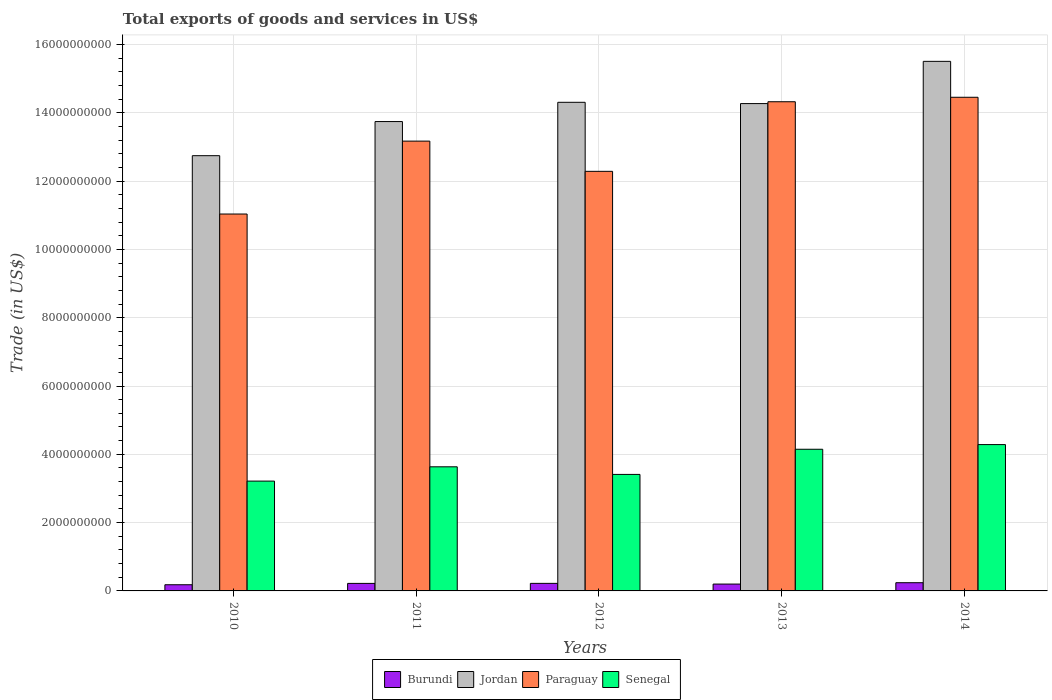How many groups of bars are there?
Your answer should be compact. 5. Are the number of bars per tick equal to the number of legend labels?
Offer a terse response. Yes. What is the label of the 3rd group of bars from the left?
Your answer should be compact. 2012. In how many cases, is the number of bars for a given year not equal to the number of legend labels?
Your answer should be compact. 0. What is the total exports of goods and services in Senegal in 2010?
Keep it short and to the point. 3.22e+09. Across all years, what is the maximum total exports of goods and services in Paraguay?
Provide a succinct answer. 1.45e+1. Across all years, what is the minimum total exports of goods and services in Senegal?
Offer a terse response. 3.22e+09. In which year was the total exports of goods and services in Paraguay minimum?
Offer a very short reply. 2010. What is the total total exports of goods and services in Burundi in the graph?
Provide a succinct answer. 1.06e+09. What is the difference between the total exports of goods and services in Paraguay in 2010 and that in 2011?
Provide a succinct answer. -2.13e+09. What is the difference between the total exports of goods and services in Senegal in 2011 and the total exports of goods and services in Paraguay in 2013?
Ensure brevity in your answer.  -1.07e+1. What is the average total exports of goods and services in Burundi per year?
Your response must be concise. 2.13e+08. In the year 2012, what is the difference between the total exports of goods and services in Burundi and total exports of goods and services in Paraguay?
Provide a succinct answer. -1.21e+1. In how many years, is the total exports of goods and services in Paraguay greater than 13600000000 US$?
Provide a succinct answer. 2. What is the ratio of the total exports of goods and services in Burundi in 2010 to that in 2012?
Your response must be concise. 0.82. What is the difference between the highest and the second highest total exports of goods and services in Jordan?
Offer a terse response. 1.20e+09. What is the difference between the highest and the lowest total exports of goods and services in Senegal?
Offer a very short reply. 1.07e+09. In how many years, is the total exports of goods and services in Senegal greater than the average total exports of goods and services in Senegal taken over all years?
Offer a terse response. 2. What does the 3rd bar from the left in 2014 represents?
Your answer should be very brief. Paraguay. What does the 4th bar from the right in 2011 represents?
Ensure brevity in your answer.  Burundi. Is it the case that in every year, the sum of the total exports of goods and services in Paraguay and total exports of goods and services in Jordan is greater than the total exports of goods and services in Senegal?
Offer a terse response. Yes. How many bars are there?
Provide a succinct answer. 20. Are all the bars in the graph horizontal?
Offer a very short reply. No. How many years are there in the graph?
Provide a succinct answer. 5. Does the graph contain grids?
Your answer should be very brief. Yes. What is the title of the graph?
Your answer should be compact. Total exports of goods and services in US$. Does "Latvia" appear as one of the legend labels in the graph?
Offer a terse response. No. What is the label or title of the X-axis?
Offer a very short reply. Years. What is the label or title of the Y-axis?
Keep it short and to the point. Trade (in US$). What is the Trade (in US$) in Burundi in 2010?
Provide a short and direct response. 1.81e+08. What is the Trade (in US$) in Jordan in 2010?
Provide a short and direct response. 1.27e+1. What is the Trade (in US$) in Paraguay in 2010?
Your answer should be very brief. 1.10e+1. What is the Trade (in US$) in Senegal in 2010?
Keep it short and to the point. 3.22e+09. What is the Trade (in US$) in Burundi in 2011?
Make the answer very short. 2.20e+08. What is the Trade (in US$) in Jordan in 2011?
Give a very brief answer. 1.37e+1. What is the Trade (in US$) of Paraguay in 2011?
Keep it short and to the point. 1.32e+1. What is the Trade (in US$) in Senegal in 2011?
Offer a terse response. 3.63e+09. What is the Trade (in US$) of Burundi in 2012?
Make the answer very short. 2.21e+08. What is the Trade (in US$) in Jordan in 2012?
Offer a very short reply. 1.43e+1. What is the Trade (in US$) in Paraguay in 2012?
Offer a very short reply. 1.23e+1. What is the Trade (in US$) of Senegal in 2012?
Your answer should be compact. 3.41e+09. What is the Trade (in US$) in Burundi in 2013?
Make the answer very short. 2.01e+08. What is the Trade (in US$) in Jordan in 2013?
Keep it short and to the point. 1.43e+1. What is the Trade (in US$) in Paraguay in 2013?
Offer a very short reply. 1.43e+1. What is the Trade (in US$) in Senegal in 2013?
Offer a terse response. 4.15e+09. What is the Trade (in US$) in Burundi in 2014?
Offer a terse response. 2.40e+08. What is the Trade (in US$) of Jordan in 2014?
Make the answer very short. 1.55e+1. What is the Trade (in US$) of Paraguay in 2014?
Provide a succinct answer. 1.45e+1. What is the Trade (in US$) in Senegal in 2014?
Offer a terse response. 4.29e+09. Across all years, what is the maximum Trade (in US$) of Burundi?
Ensure brevity in your answer.  2.40e+08. Across all years, what is the maximum Trade (in US$) of Jordan?
Provide a succinct answer. 1.55e+1. Across all years, what is the maximum Trade (in US$) in Paraguay?
Your answer should be compact. 1.45e+1. Across all years, what is the maximum Trade (in US$) in Senegal?
Ensure brevity in your answer.  4.29e+09. Across all years, what is the minimum Trade (in US$) of Burundi?
Offer a terse response. 1.81e+08. Across all years, what is the minimum Trade (in US$) of Jordan?
Your answer should be compact. 1.27e+1. Across all years, what is the minimum Trade (in US$) in Paraguay?
Your answer should be compact. 1.10e+1. Across all years, what is the minimum Trade (in US$) in Senegal?
Your response must be concise. 3.22e+09. What is the total Trade (in US$) of Burundi in the graph?
Your answer should be compact. 1.06e+09. What is the total Trade (in US$) in Jordan in the graph?
Offer a terse response. 7.06e+1. What is the total Trade (in US$) of Paraguay in the graph?
Make the answer very short. 6.53e+1. What is the total Trade (in US$) of Senegal in the graph?
Keep it short and to the point. 1.87e+1. What is the difference between the Trade (in US$) of Burundi in 2010 and that in 2011?
Offer a terse response. -3.96e+07. What is the difference between the Trade (in US$) of Jordan in 2010 and that in 2011?
Make the answer very short. -9.99e+08. What is the difference between the Trade (in US$) of Paraguay in 2010 and that in 2011?
Keep it short and to the point. -2.13e+09. What is the difference between the Trade (in US$) in Senegal in 2010 and that in 2011?
Provide a short and direct response. -4.19e+08. What is the difference between the Trade (in US$) of Burundi in 2010 and that in 2012?
Ensure brevity in your answer.  -4.06e+07. What is the difference between the Trade (in US$) of Jordan in 2010 and that in 2012?
Give a very brief answer. -1.56e+09. What is the difference between the Trade (in US$) in Paraguay in 2010 and that in 2012?
Your answer should be compact. -1.25e+09. What is the difference between the Trade (in US$) in Senegal in 2010 and that in 2012?
Your answer should be compact. -1.96e+08. What is the difference between the Trade (in US$) of Burundi in 2010 and that in 2013?
Your answer should be compact. -2.00e+07. What is the difference between the Trade (in US$) in Jordan in 2010 and that in 2013?
Ensure brevity in your answer.  -1.53e+09. What is the difference between the Trade (in US$) in Paraguay in 2010 and that in 2013?
Your answer should be very brief. -3.29e+09. What is the difference between the Trade (in US$) in Senegal in 2010 and that in 2013?
Keep it short and to the point. -9.32e+08. What is the difference between the Trade (in US$) of Burundi in 2010 and that in 2014?
Ensure brevity in your answer.  -5.96e+07. What is the difference between the Trade (in US$) of Jordan in 2010 and that in 2014?
Keep it short and to the point. -2.76e+09. What is the difference between the Trade (in US$) in Paraguay in 2010 and that in 2014?
Provide a short and direct response. -3.42e+09. What is the difference between the Trade (in US$) of Senegal in 2010 and that in 2014?
Offer a terse response. -1.07e+09. What is the difference between the Trade (in US$) of Burundi in 2011 and that in 2012?
Provide a succinct answer. -9.41e+05. What is the difference between the Trade (in US$) in Jordan in 2011 and that in 2012?
Give a very brief answer. -5.64e+08. What is the difference between the Trade (in US$) in Paraguay in 2011 and that in 2012?
Provide a succinct answer. 8.85e+08. What is the difference between the Trade (in US$) in Senegal in 2011 and that in 2012?
Your answer should be compact. 2.23e+08. What is the difference between the Trade (in US$) of Burundi in 2011 and that in 2013?
Keep it short and to the point. 1.96e+07. What is the difference between the Trade (in US$) in Jordan in 2011 and that in 2013?
Give a very brief answer. -5.26e+08. What is the difference between the Trade (in US$) in Paraguay in 2011 and that in 2013?
Your answer should be very brief. -1.15e+09. What is the difference between the Trade (in US$) of Senegal in 2011 and that in 2013?
Your response must be concise. -5.14e+08. What is the difference between the Trade (in US$) of Burundi in 2011 and that in 2014?
Ensure brevity in your answer.  -2.00e+07. What is the difference between the Trade (in US$) of Jordan in 2011 and that in 2014?
Ensure brevity in your answer.  -1.76e+09. What is the difference between the Trade (in US$) of Paraguay in 2011 and that in 2014?
Provide a short and direct response. -1.28e+09. What is the difference between the Trade (in US$) in Senegal in 2011 and that in 2014?
Your answer should be compact. -6.51e+08. What is the difference between the Trade (in US$) of Burundi in 2012 and that in 2013?
Provide a short and direct response. 2.05e+07. What is the difference between the Trade (in US$) in Jordan in 2012 and that in 2013?
Your response must be concise. 3.72e+07. What is the difference between the Trade (in US$) in Paraguay in 2012 and that in 2013?
Ensure brevity in your answer.  -2.04e+09. What is the difference between the Trade (in US$) of Senegal in 2012 and that in 2013?
Give a very brief answer. -7.36e+08. What is the difference between the Trade (in US$) of Burundi in 2012 and that in 2014?
Give a very brief answer. -1.90e+07. What is the difference between the Trade (in US$) in Jordan in 2012 and that in 2014?
Offer a very short reply. -1.20e+09. What is the difference between the Trade (in US$) of Paraguay in 2012 and that in 2014?
Keep it short and to the point. -2.17e+09. What is the difference between the Trade (in US$) in Senegal in 2012 and that in 2014?
Your answer should be compact. -8.73e+08. What is the difference between the Trade (in US$) in Burundi in 2013 and that in 2014?
Your answer should be very brief. -3.96e+07. What is the difference between the Trade (in US$) of Jordan in 2013 and that in 2014?
Offer a very short reply. -1.24e+09. What is the difference between the Trade (in US$) of Paraguay in 2013 and that in 2014?
Your response must be concise. -1.31e+08. What is the difference between the Trade (in US$) of Senegal in 2013 and that in 2014?
Make the answer very short. -1.37e+08. What is the difference between the Trade (in US$) of Burundi in 2010 and the Trade (in US$) of Jordan in 2011?
Offer a very short reply. -1.36e+1. What is the difference between the Trade (in US$) of Burundi in 2010 and the Trade (in US$) of Paraguay in 2011?
Your answer should be very brief. -1.30e+1. What is the difference between the Trade (in US$) of Burundi in 2010 and the Trade (in US$) of Senegal in 2011?
Ensure brevity in your answer.  -3.45e+09. What is the difference between the Trade (in US$) of Jordan in 2010 and the Trade (in US$) of Paraguay in 2011?
Give a very brief answer. -4.27e+08. What is the difference between the Trade (in US$) of Jordan in 2010 and the Trade (in US$) of Senegal in 2011?
Your answer should be very brief. 9.11e+09. What is the difference between the Trade (in US$) of Paraguay in 2010 and the Trade (in US$) of Senegal in 2011?
Make the answer very short. 7.40e+09. What is the difference between the Trade (in US$) of Burundi in 2010 and the Trade (in US$) of Jordan in 2012?
Make the answer very short. -1.41e+1. What is the difference between the Trade (in US$) of Burundi in 2010 and the Trade (in US$) of Paraguay in 2012?
Provide a short and direct response. -1.21e+1. What is the difference between the Trade (in US$) in Burundi in 2010 and the Trade (in US$) in Senegal in 2012?
Offer a terse response. -3.23e+09. What is the difference between the Trade (in US$) in Jordan in 2010 and the Trade (in US$) in Paraguay in 2012?
Your answer should be very brief. 4.58e+08. What is the difference between the Trade (in US$) of Jordan in 2010 and the Trade (in US$) of Senegal in 2012?
Your answer should be compact. 9.33e+09. What is the difference between the Trade (in US$) in Paraguay in 2010 and the Trade (in US$) in Senegal in 2012?
Make the answer very short. 7.62e+09. What is the difference between the Trade (in US$) in Burundi in 2010 and the Trade (in US$) in Jordan in 2013?
Keep it short and to the point. -1.41e+1. What is the difference between the Trade (in US$) of Burundi in 2010 and the Trade (in US$) of Paraguay in 2013?
Make the answer very short. -1.41e+1. What is the difference between the Trade (in US$) in Burundi in 2010 and the Trade (in US$) in Senegal in 2013?
Keep it short and to the point. -3.97e+09. What is the difference between the Trade (in US$) of Jordan in 2010 and the Trade (in US$) of Paraguay in 2013?
Provide a succinct answer. -1.58e+09. What is the difference between the Trade (in US$) in Jordan in 2010 and the Trade (in US$) in Senegal in 2013?
Provide a short and direct response. 8.60e+09. What is the difference between the Trade (in US$) of Paraguay in 2010 and the Trade (in US$) of Senegal in 2013?
Provide a succinct answer. 6.89e+09. What is the difference between the Trade (in US$) in Burundi in 2010 and the Trade (in US$) in Jordan in 2014?
Provide a succinct answer. -1.53e+1. What is the difference between the Trade (in US$) in Burundi in 2010 and the Trade (in US$) in Paraguay in 2014?
Provide a succinct answer. -1.43e+1. What is the difference between the Trade (in US$) of Burundi in 2010 and the Trade (in US$) of Senegal in 2014?
Give a very brief answer. -4.10e+09. What is the difference between the Trade (in US$) in Jordan in 2010 and the Trade (in US$) in Paraguay in 2014?
Your answer should be compact. -1.71e+09. What is the difference between the Trade (in US$) of Jordan in 2010 and the Trade (in US$) of Senegal in 2014?
Provide a succinct answer. 8.46e+09. What is the difference between the Trade (in US$) in Paraguay in 2010 and the Trade (in US$) in Senegal in 2014?
Your answer should be compact. 6.75e+09. What is the difference between the Trade (in US$) of Burundi in 2011 and the Trade (in US$) of Jordan in 2012?
Your answer should be very brief. -1.41e+1. What is the difference between the Trade (in US$) of Burundi in 2011 and the Trade (in US$) of Paraguay in 2012?
Your answer should be very brief. -1.21e+1. What is the difference between the Trade (in US$) of Burundi in 2011 and the Trade (in US$) of Senegal in 2012?
Provide a short and direct response. -3.19e+09. What is the difference between the Trade (in US$) in Jordan in 2011 and the Trade (in US$) in Paraguay in 2012?
Your answer should be very brief. 1.46e+09. What is the difference between the Trade (in US$) in Jordan in 2011 and the Trade (in US$) in Senegal in 2012?
Your answer should be compact. 1.03e+1. What is the difference between the Trade (in US$) in Paraguay in 2011 and the Trade (in US$) in Senegal in 2012?
Make the answer very short. 9.76e+09. What is the difference between the Trade (in US$) of Burundi in 2011 and the Trade (in US$) of Jordan in 2013?
Provide a short and direct response. -1.40e+1. What is the difference between the Trade (in US$) in Burundi in 2011 and the Trade (in US$) in Paraguay in 2013?
Give a very brief answer. -1.41e+1. What is the difference between the Trade (in US$) in Burundi in 2011 and the Trade (in US$) in Senegal in 2013?
Your answer should be compact. -3.93e+09. What is the difference between the Trade (in US$) in Jordan in 2011 and the Trade (in US$) in Paraguay in 2013?
Keep it short and to the point. -5.80e+08. What is the difference between the Trade (in US$) of Jordan in 2011 and the Trade (in US$) of Senegal in 2013?
Offer a very short reply. 9.60e+09. What is the difference between the Trade (in US$) in Paraguay in 2011 and the Trade (in US$) in Senegal in 2013?
Provide a succinct answer. 9.02e+09. What is the difference between the Trade (in US$) in Burundi in 2011 and the Trade (in US$) in Jordan in 2014?
Give a very brief answer. -1.53e+1. What is the difference between the Trade (in US$) of Burundi in 2011 and the Trade (in US$) of Paraguay in 2014?
Keep it short and to the point. -1.42e+1. What is the difference between the Trade (in US$) in Burundi in 2011 and the Trade (in US$) in Senegal in 2014?
Offer a very short reply. -4.06e+09. What is the difference between the Trade (in US$) of Jordan in 2011 and the Trade (in US$) of Paraguay in 2014?
Provide a short and direct response. -7.11e+08. What is the difference between the Trade (in US$) of Jordan in 2011 and the Trade (in US$) of Senegal in 2014?
Offer a very short reply. 9.46e+09. What is the difference between the Trade (in US$) in Paraguay in 2011 and the Trade (in US$) in Senegal in 2014?
Keep it short and to the point. 8.89e+09. What is the difference between the Trade (in US$) of Burundi in 2012 and the Trade (in US$) of Jordan in 2013?
Your response must be concise. -1.40e+1. What is the difference between the Trade (in US$) in Burundi in 2012 and the Trade (in US$) in Paraguay in 2013?
Provide a short and direct response. -1.41e+1. What is the difference between the Trade (in US$) in Burundi in 2012 and the Trade (in US$) in Senegal in 2013?
Your answer should be compact. -3.93e+09. What is the difference between the Trade (in US$) in Jordan in 2012 and the Trade (in US$) in Paraguay in 2013?
Your answer should be very brief. -1.66e+07. What is the difference between the Trade (in US$) of Jordan in 2012 and the Trade (in US$) of Senegal in 2013?
Provide a succinct answer. 1.02e+1. What is the difference between the Trade (in US$) in Paraguay in 2012 and the Trade (in US$) in Senegal in 2013?
Your response must be concise. 8.14e+09. What is the difference between the Trade (in US$) of Burundi in 2012 and the Trade (in US$) of Jordan in 2014?
Keep it short and to the point. -1.53e+1. What is the difference between the Trade (in US$) of Burundi in 2012 and the Trade (in US$) of Paraguay in 2014?
Provide a succinct answer. -1.42e+1. What is the difference between the Trade (in US$) in Burundi in 2012 and the Trade (in US$) in Senegal in 2014?
Your response must be concise. -4.06e+09. What is the difference between the Trade (in US$) in Jordan in 2012 and the Trade (in US$) in Paraguay in 2014?
Give a very brief answer. -1.48e+08. What is the difference between the Trade (in US$) in Jordan in 2012 and the Trade (in US$) in Senegal in 2014?
Provide a succinct answer. 1.00e+1. What is the difference between the Trade (in US$) in Paraguay in 2012 and the Trade (in US$) in Senegal in 2014?
Provide a short and direct response. 8.00e+09. What is the difference between the Trade (in US$) in Burundi in 2013 and the Trade (in US$) in Jordan in 2014?
Provide a short and direct response. -1.53e+1. What is the difference between the Trade (in US$) of Burundi in 2013 and the Trade (in US$) of Paraguay in 2014?
Offer a terse response. -1.43e+1. What is the difference between the Trade (in US$) in Burundi in 2013 and the Trade (in US$) in Senegal in 2014?
Make the answer very short. -4.08e+09. What is the difference between the Trade (in US$) in Jordan in 2013 and the Trade (in US$) in Paraguay in 2014?
Give a very brief answer. -1.85e+08. What is the difference between the Trade (in US$) in Jordan in 2013 and the Trade (in US$) in Senegal in 2014?
Give a very brief answer. 9.99e+09. What is the difference between the Trade (in US$) of Paraguay in 2013 and the Trade (in US$) of Senegal in 2014?
Ensure brevity in your answer.  1.00e+1. What is the average Trade (in US$) in Burundi per year?
Your answer should be compact. 2.13e+08. What is the average Trade (in US$) in Jordan per year?
Your answer should be compact. 1.41e+1. What is the average Trade (in US$) of Paraguay per year?
Ensure brevity in your answer.  1.31e+1. What is the average Trade (in US$) of Senegal per year?
Keep it short and to the point. 3.74e+09. In the year 2010, what is the difference between the Trade (in US$) of Burundi and Trade (in US$) of Jordan?
Your answer should be compact. -1.26e+1. In the year 2010, what is the difference between the Trade (in US$) of Burundi and Trade (in US$) of Paraguay?
Your answer should be compact. -1.09e+1. In the year 2010, what is the difference between the Trade (in US$) in Burundi and Trade (in US$) in Senegal?
Give a very brief answer. -3.03e+09. In the year 2010, what is the difference between the Trade (in US$) of Jordan and Trade (in US$) of Paraguay?
Keep it short and to the point. 1.71e+09. In the year 2010, what is the difference between the Trade (in US$) of Jordan and Trade (in US$) of Senegal?
Offer a very short reply. 9.53e+09. In the year 2010, what is the difference between the Trade (in US$) in Paraguay and Trade (in US$) in Senegal?
Your answer should be compact. 7.82e+09. In the year 2011, what is the difference between the Trade (in US$) of Burundi and Trade (in US$) of Jordan?
Keep it short and to the point. -1.35e+1. In the year 2011, what is the difference between the Trade (in US$) of Burundi and Trade (in US$) of Paraguay?
Offer a very short reply. -1.30e+1. In the year 2011, what is the difference between the Trade (in US$) of Burundi and Trade (in US$) of Senegal?
Your response must be concise. -3.41e+09. In the year 2011, what is the difference between the Trade (in US$) in Jordan and Trade (in US$) in Paraguay?
Give a very brief answer. 5.73e+08. In the year 2011, what is the difference between the Trade (in US$) in Jordan and Trade (in US$) in Senegal?
Ensure brevity in your answer.  1.01e+1. In the year 2011, what is the difference between the Trade (in US$) of Paraguay and Trade (in US$) of Senegal?
Your answer should be very brief. 9.54e+09. In the year 2012, what is the difference between the Trade (in US$) in Burundi and Trade (in US$) in Jordan?
Give a very brief answer. -1.41e+1. In the year 2012, what is the difference between the Trade (in US$) in Burundi and Trade (in US$) in Paraguay?
Offer a very short reply. -1.21e+1. In the year 2012, what is the difference between the Trade (in US$) of Burundi and Trade (in US$) of Senegal?
Provide a succinct answer. -3.19e+09. In the year 2012, what is the difference between the Trade (in US$) of Jordan and Trade (in US$) of Paraguay?
Your response must be concise. 2.02e+09. In the year 2012, what is the difference between the Trade (in US$) in Jordan and Trade (in US$) in Senegal?
Make the answer very short. 1.09e+1. In the year 2012, what is the difference between the Trade (in US$) in Paraguay and Trade (in US$) in Senegal?
Give a very brief answer. 8.87e+09. In the year 2013, what is the difference between the Trade (in US$) in Burundi and Trade (in US$) in Jordan?
Offer a very short reply. -1.41e+1. In the year 2013, what is the difference between the Trade (in US$) in Burundi and Trade (in US$) in Paraguay?
Your response must be concise. -1.41e+1. In the year 2013, what is the difference between the Trade (in US$) in Burundi and Trade (in US$) in Senegal?
Make the answer very short. -3.95e+09. In the year 2013, what is the difference between the Trade (in US$) of Jordan and Trade (in US$) of Paraguay?
Give a very brief answer. -5.37e+07. In the year 2013, what is the difference between the Trade (in US$) of Jordan and Trade (in US$) of Senegal?
Keep it short and to the point. 1.01e+1. In the year 2013, what is the difference between the Trade (in US$) of Paraguay and Trade (in US$) of Senegal?
Your response must be concise. 1.02e+1. In the year 2014, what is the difference between the Trade (in US$) of Burundi and Trade (in US$) of Jordan?
Keep it short and to the point. -1.53e+1. In the year 2014, what is the difference between the Trade (in US$) in Burundi and Trade (in US$) in Paraguay?
Offer a terse response. -1.42e+1. In the year 2014, what is the difference between the Trade (in US$) of Burundi and Trade (in US$) of Senegal?
Ensure brevity in your answer.  -4.04e+09. In the year 2014, what is the difference between the Trade (in US$) in Jordan and Trade (in US$) in Paraguay?
Ensure brevity in your answer.  1.05e+09. In the year 2014, what is the difference between the Trade (in US$) in Jordan and Trade (in US$) in Senegal?
Give a very brief answer. 1.12e+1. In the year 2014, what is the difference between the Trade (in US$) of Paraguay and Trade (in US$) of Senegal?
Your response must be concise. 1.02e+1. What is the ratio of the Trade (in US$) of Burundi in 2010 to that in 2011?
Give a very brief answer. 0.82. What is the ratio of the Trade (in US$) of Jordan in 2010 to that in 2011?
Offer a terse response. 0.93. What is the ratio of the Trade (in US$) in Paraguay in 2010 to that in 2011?
Offer a terse response. 0.84. What is the ratio of the Trade (in US$) in Senegal in 2010 to that in 2011?
Give a very brief answer. 0.88. What is the ratio of the Trade (in US$) in Burundi in 2010 to that in 2012?
Your answer should be compact. 0.82. What is the ratio of the Trade (in US$) in Jordan in 2010 to that in 2012?
Provide a short and direct response. 0.89. What is the ratio of the Trade (in US$) of Paraguay in 2010 to that in 2012?
Provide a short and direct response. 0.9. What is the ratio of the Trade (in US$) in Senegal in 2010 to that in 2012?
Make the answer very short. 0.94. What is the ratio of the Trade (in US$) in Burundi in 2010 to that in 2013?
Your answer should be very brief. 0.9. What is the ratio of the Trade (in US$) of Jordan in 2010 to that in 2013?
Keep it short and to the point. 0.89. What is the ratio of the Trade (in US$) in Paraguay in 2010 to that in 2013?
Give a very brief answer. 0.77. What is the ratio of the Trade (in US$) of Senegal in 2010 to that in 2013?
Keep it short and to the point. 0.78. What is the ratio of the Trade (in US$) of Burundi in 2010 to that in 2014?
Make the answer very short. 0.75. What is the ratio of the Trade (in US$) of Jordan in 2010 to that in 2014?
Ensure brevity in your answer.  0.82. What is the ratio of the Trade (in US$) of Paraguay in 2010 to that in 2014?
Offer a very short reply. 0.76. What is the ratio of the Trade (in US$) in Senegal in 2010 to that in 2014?
Your answer should be very brief. 0.75. What is the ratio of the Trade (in US$) of Burundi in 2011 to that in 2012?
Your response must be concise. 1. What is the ratio of the Trade (in US$) of Jordan in 2011 to that in 2012?
Your answer should be very brief. 0.96. What is the ratio of the Trade (in US$) in Paraguay in 2011 to that in 2012?
Offer a very short reply. 1.07. What is the ratio of the Trade (in US$) of Senegal in 2011 to that in 2012?
Keep it short and to the point. 1.07. What is the ratio of the Trade (in US$) in Burundi in 2011 to that in 2013?
Your answer should be compact. 1.1. What is the ratio of the Trade (in US$) of Jordan in 2011 to that in 2013?
Offer a terse response. 0.96. What is the ratio of the Trade (in US$) of Paraguay in 2011 to that in 2013?
Your response must be concise. 0.92. What is the ratio of the Trade (in US$) in Senegal in 2011 to that in 2013?
Give a very brief answer. 0.88. What is the ratio of the Trade (in US$) in Burundi in 2011 to that in 2014?
Provide a short and direct response. 0.92. What is the ratio of the Trade (in US$) of Jordan in 2011 to that in 2014?
Offer a very short reply. 0.89. What is the ratio of the Trade (in US$) in Paraguay in 2011 to that in 2014?
Your answer should be very brief. 0.91. What is the ratio of the Trade (in US$) of Senegal in 2011 to that in 2014?
Your answer should be compact. 0.85. What is the ratio of the Trade (in US$) in Burundi in 2012 to that in 2013?
Your answer should be very brief. 1.1. What is the ratio of the Trade (in US$) in Jordan in 2012 to that in 2013?
Offer a very short reply. 1. What is the ratio of the Trade (in US$) of Paraguay in 2012 to that in 2013?
Keep it short and to the point. 0.86. What is the ratio of the Trade (in US$) of Senegal in 2012 to that in 2013?
Give a very brief answer. 0.82. What is the ratio of the Trade (in US$) of Burundi in 2012 to that in 2014?
Make the answer very short. 0.92. What is the ratio of the Trade (in US$) in Jordan in 2012 to that in 2014?
Offer a terse response. 0.92. What is the ratio of the Trade (in US$) of Senegal in 2012 to that in 2014?
Offer a terse response. 0.8. What is the ratio of the Trade (in US$) in Burundi in 2013 to that in 2014?
Make the answer very short. 0.84. What is the ratio of the Trade (in US$) in Jordan in 2013 to that in 2014?
Your answer should be compact. 0.92. What is the ratio of the Trade (in US$) of Paraguay in 2013 to that in 2014?
Give a very brief answer. 0.99. What is the difference between the highest and the second highest Trade (in US$) of Burundi?
Offer a terse response. 1.90e+07. What is the difference between the highest and the second highest Trade (in US$) of Jordan?
Ensure brevity in your answer.  1.20e+09. What is the difference between the highest and the second highest Trade (in US$) of Paraguay?
Offer a terse response. 1.31e+08. What is the difference between the highest and the second highest Trade (in US$) of Senegal?
Your response must be concise. 1.37e+08. What is the difference between the highest and the lowest Trade (in US$) in Burundi?
Your answer should be very brief. 5.96e+07. What is the difference between the highest and the lowest Trade (in US$) of Jordan?
Ensure brevity in your answer.  2.76e+09. What is the difference between the highest and the lowest Trade (in US$) in Paraguay?
Provide a succinct answer. 3.42e+09. What is the difference between the highest and the lowest Trade (in US$) in Senegal?
Your answer should be compact. 1.07e+09. 